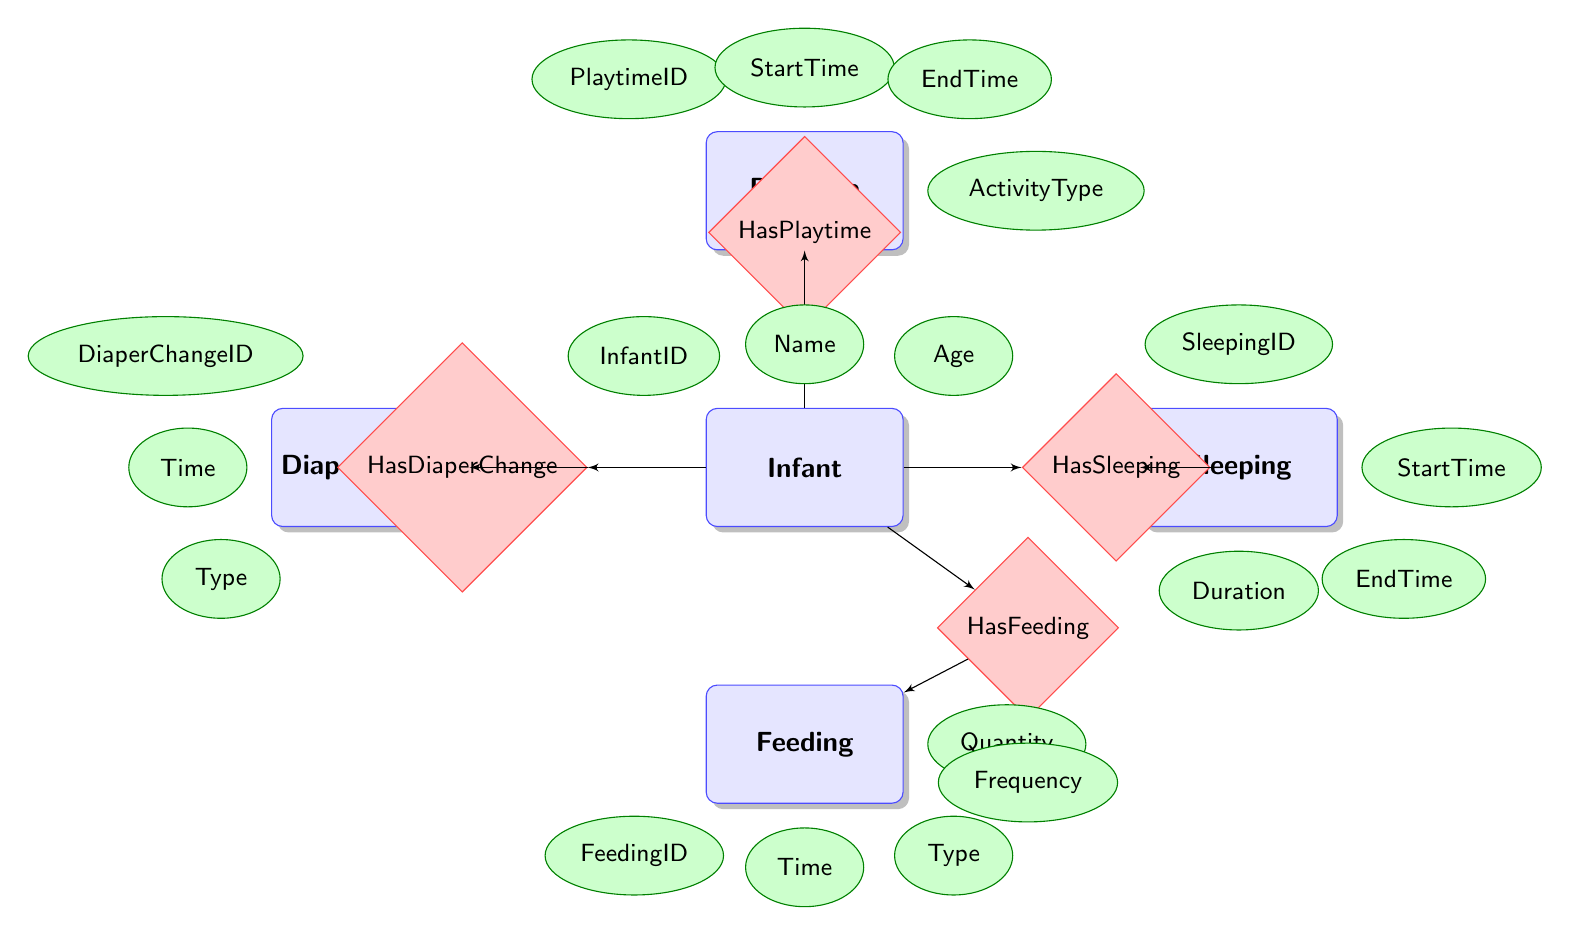What is the primary entity in the diagram? The primary entity in the diagram is "Infant," as it is the central focus connecting to all other entities through relationships.
Answer: Infant How many attributes does the Feeding entity have? The Feeding entity has four attributes: FeedingID, Time, Type, and Quantity, identifiable by counting them in the diagram.
Answer: 4 What is the relationship between the Infant and Feeding? The relationship is called "HasFeeding," which indicates that the Infant has feeding sessions. This is confirmed by the connecting diamond shape labeled accordingly.
Answer: HasFeeding What attribute is specifically associated with the HasFeeding relationship? The attribute associated with the HasFeeding relationship is "Frequency," indicated in the diagram as connected specifically to the HasFeeding node.
Answer: Frequency Which entity has a relationship with DiaperChange? The entity that has a relationship with DiaperChange is "Infant," as shown by the direct line connecting the two nodes through the HasDiaperChange relationship.
Answer: Infant How many relationships are shown in the diagram? The diagram shows four relationships: HasFeeding, HasSleeping, HasDiaperChange, and HasPlaytime, evident by counting the diamond shapes in the diagram.
Answer: 4 What type of activity can occur during Playtime? The type of activity during Playtime is defined by the "ActivityType" attribute within the Playtime entity, indicating different possible activities.
Answer: ActivityType What is the duration considered in the Sleeping entity? The duration in the Sleeping entity is specifically described by the "Duration" attribute, which represents how long the infant sleeps.
Answer: Duration Which entity represents the actions for managing the baby's cleanliness? The DiaperChange entity represents the actions for managing the baby's cleanliness, as it records time and type of diaper change.
Answer: DiaperChange 